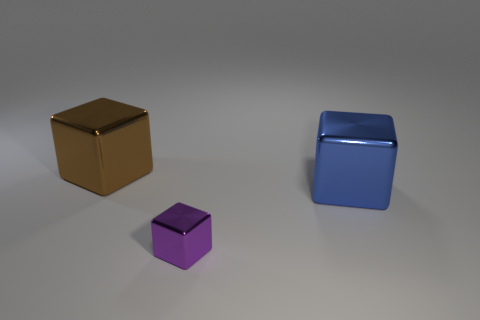Add 2 big green things. How many objects exist? 5 Subtract all large cubes. How many cubes are left? 1 Add 1 blue matte blocks. How many blue matte blocks exist? 1 Subtract all brown cubes. How many cubes are left? 2 Subtract 0 brown spheres. How many objects are left? 3 Subtract 1 blocks. How many blocks are left? 2 Subtract all cyan cubes. Subtract all purple spheres. How many cubes are left? 3 Subtract all green cylinders. How many cyan cubes are left? 0 Subtract all big yellow metal cylinders. Subtract all purple cubes. How many objects are left? 2 Add 3 metallic blocks. How many metallic blocks are left? 6 